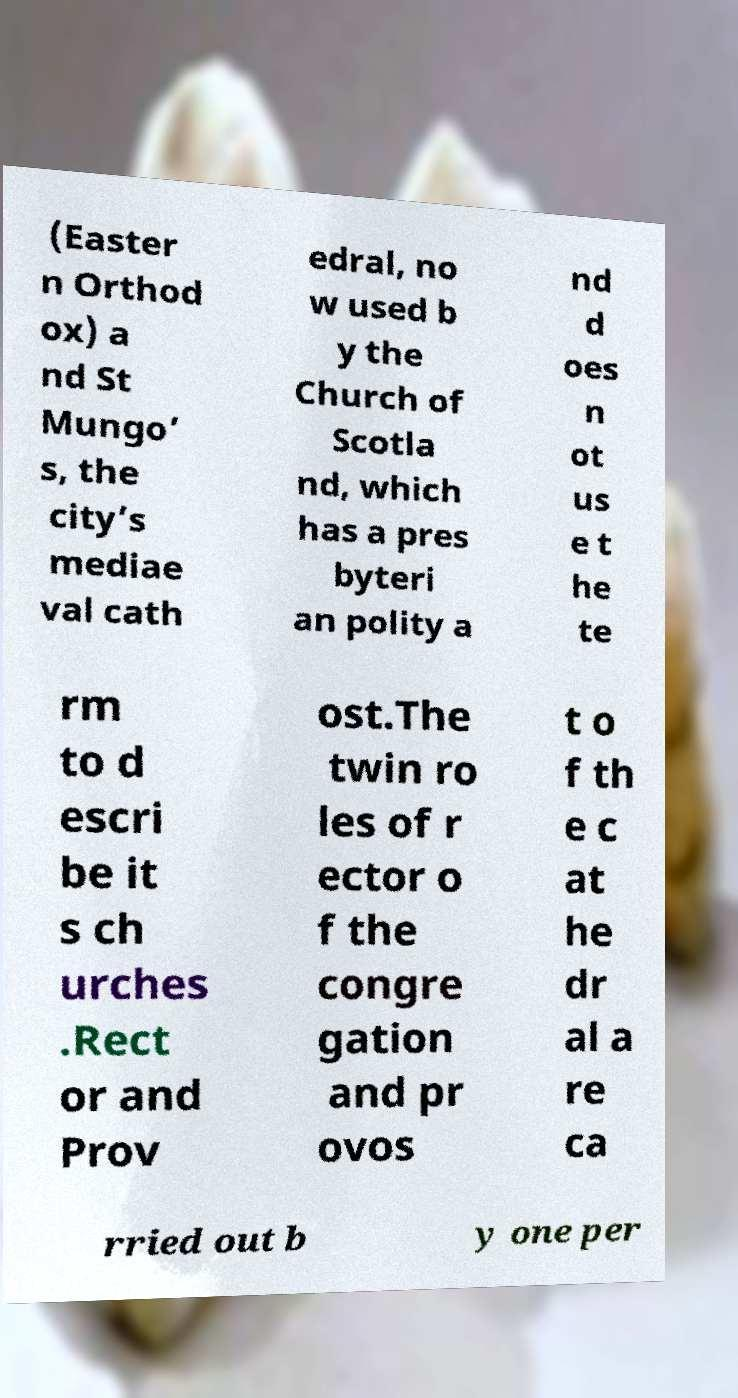For documentation purposes, I need the text within this image transcribed. Could you provide that? (Easter n Orthod ox) a nd St Mungo’ s, the city’s mediae val cath edral, no w used b y the Church of Scotla nd, which has a pres byteri an polity a nd d oes n ot us e t he te rm to d escri be it s ch urches .Rect or and Prov ost.The twin ro les of r ector o f the congre gation and pr ovos t o f th e c at he dr al a re ca rried out b y one per 